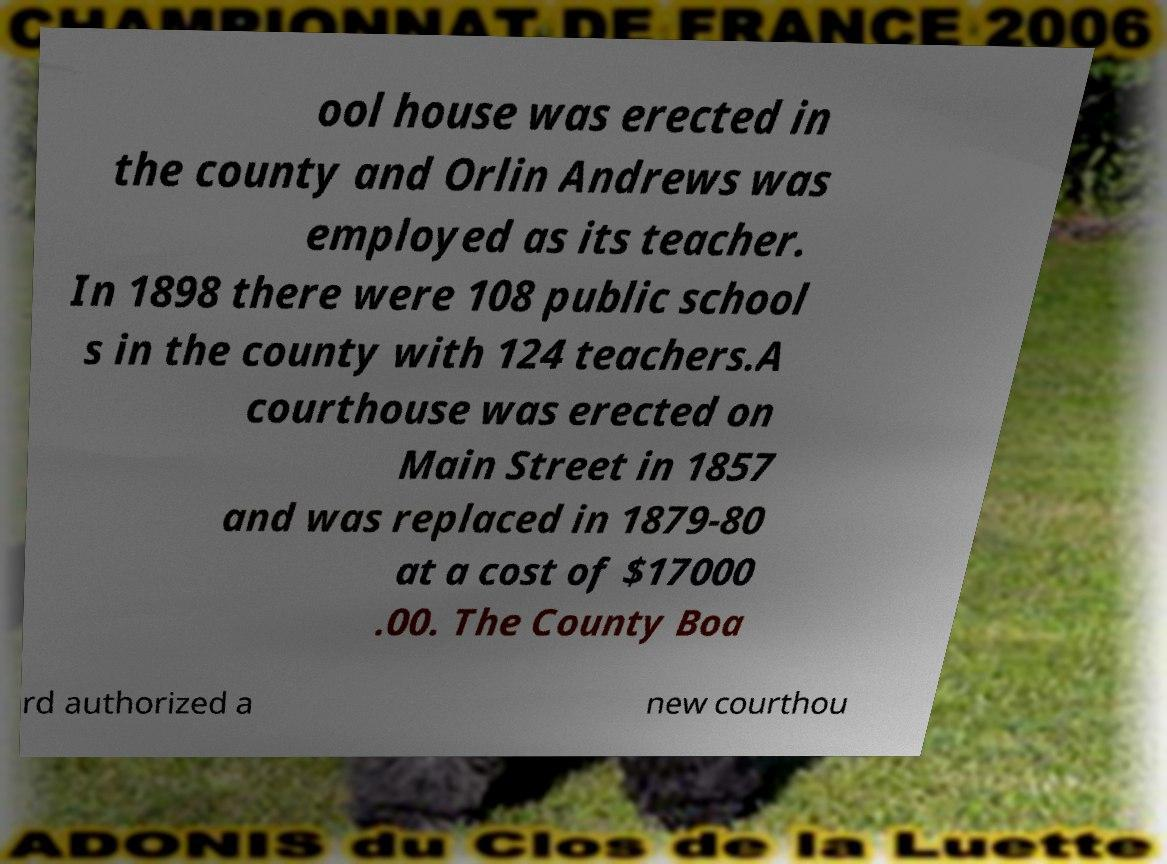Can you accurately transcribe the text from the provided image for me? ool house was erected in the county and Orlin Andrews was employed as its teacher. In 1898 there were 108 public school s in the county with 124 teachers.A courthouse was erected on Main Street in 1857 and was replaced in 1879-80 at a cost of $17000 .00. The County Boa rd authorized a new courthou 